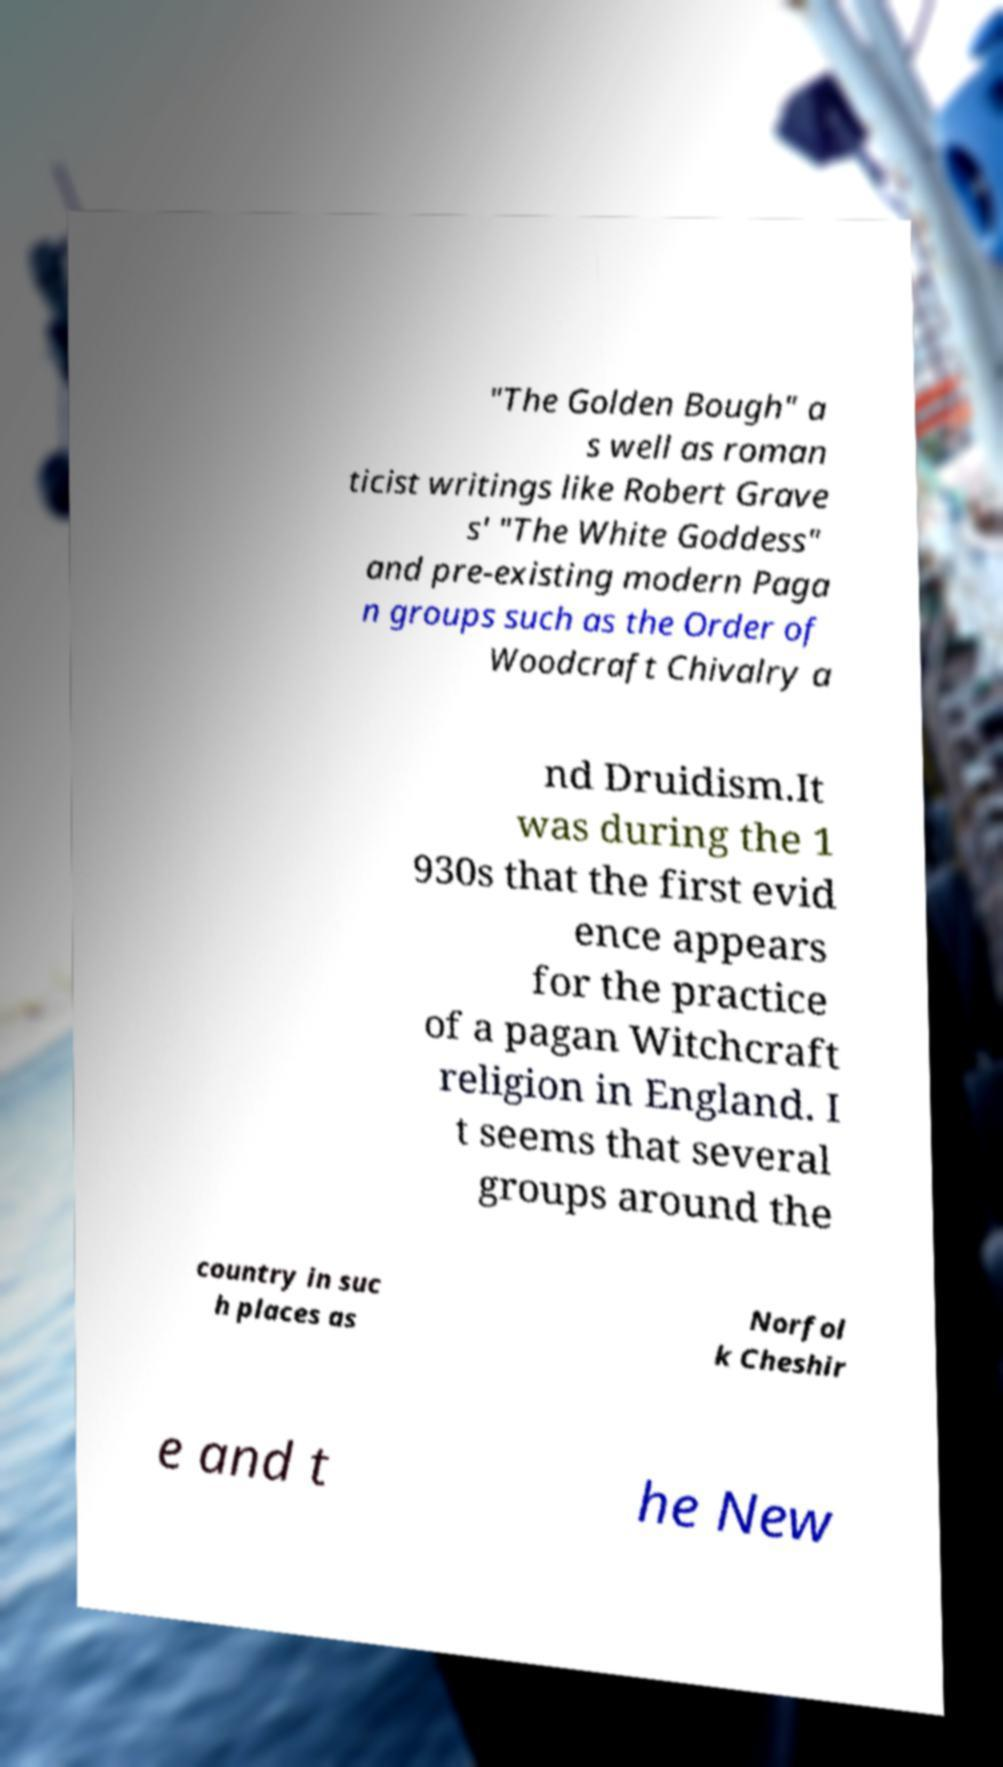Please identify and transcribe the text found in this image. "The Golden Bough" a s well as roman ticist writings like Robert Grave s' "The White Goddess" and pre-existing modern Paga n groups such as the Order of Woodcraft Chivalry a nd Druidism.It was during the 1 930s that the first evid ence appears for the practice of a pagan Witchcraft religion in England. I t seems that several groups around the country in suc h places as Norfol k Cheshir e and t he New 